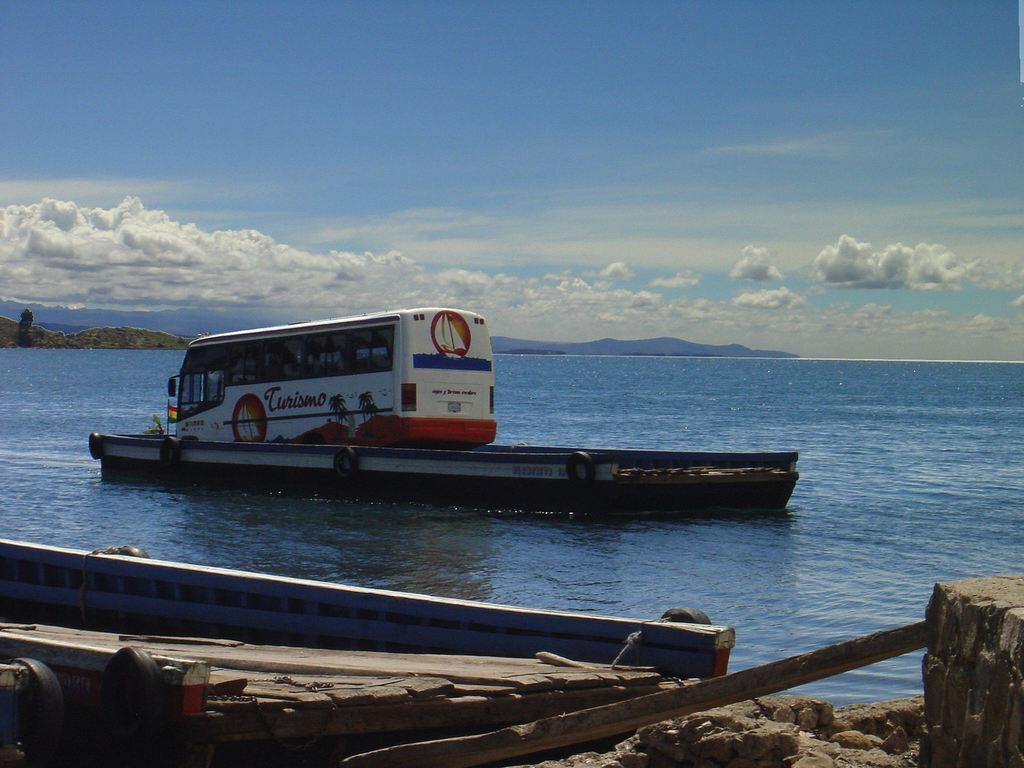What is the main subject of the image? The main subject of the image is a bus on a boat. What is the boat doing in the image? The boat is floating on water. Are there any other boats in the image? Yes, there is another boat in the image. What can be seen in the background of the image? The sky is visible in the background of the image. What type of ornament is hanging from the rod in the image? There is no rod or ornament present in the image. Can you tell me what kind of guitar is being played on the boat in the image? There is no guitar or person playing it in the image. 